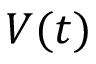<formula> <loc_0><loc_0><loc_500><loc_500>V ( t )</formula> 